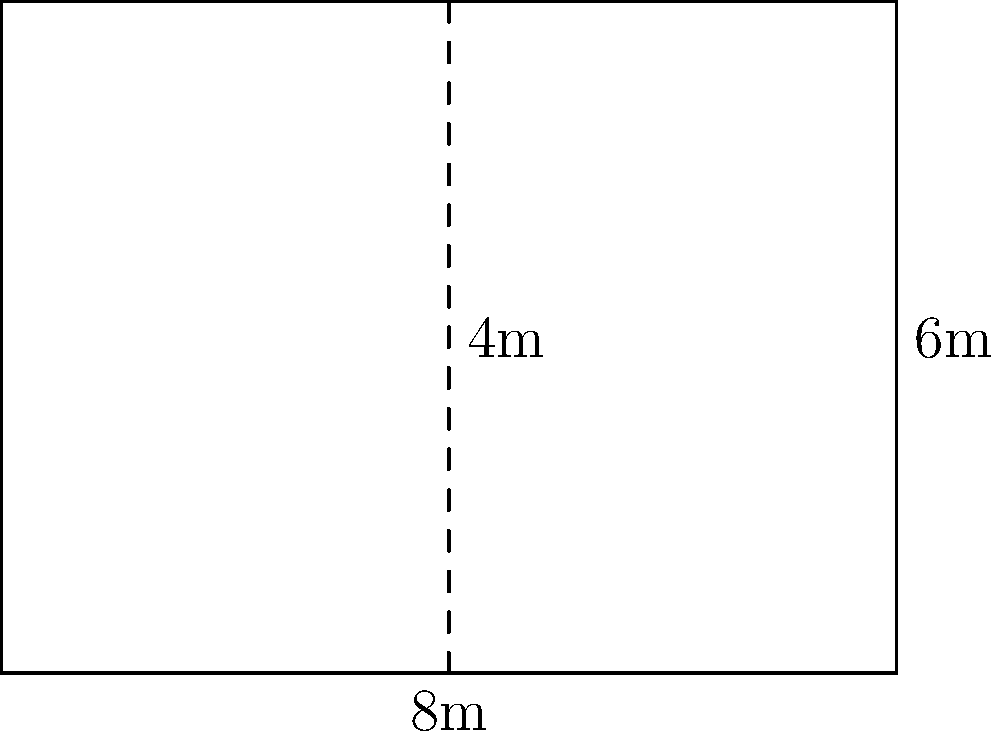You need to install new flooring in a rectangular room measuring 8m by 6m. The flooring comes in square tiles of 1m x 1m, sold in boxes of 10 tiles each. Each box costs $50. To minimize waste, you're considering cutting some tiles in half diagonally. What's the minimum cost to floor the entire room? Let's approach this step-by-step:

1) First, calculate the total area of the room:
   Area = length × width = 8m × 6m = 48m²

2) Each tile covers 1m², so we need 48 tiles to cover the room completely.

3) However, tiles are sold in boxes of 10. If we buy 5 boxes, we'll have 50 tiles, which is more than needed.

4) To minimize waste, let's consider cutting some tiles diagonally:
   - We can use 46 whole tiles to cover most of the room.
   - The remaining 2m² can be covered by 4 half-tiles (triangles).

5) So, we need 46 whole tiles + 2 tiles to be cut in half = 48 tiles in total.

6) 48 tiles require 5 boxes (as 4 boxes would only provide 40 tiles).

7) Calculate the cost:
   5 boxes × $50 per box = $250

This approach ensures we buy the minimum number of boxes while covering the entire room.
Answer: $250 